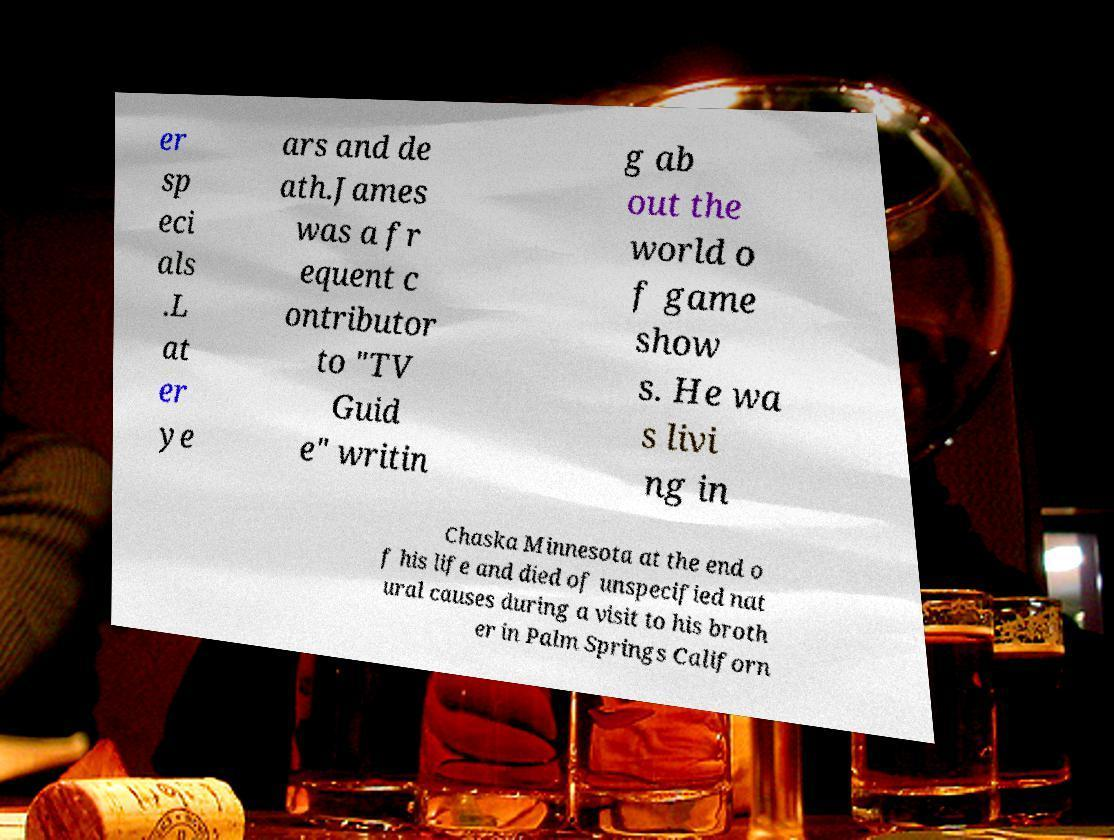There's text embedded in this image that I need extracted. Can you transcribe it verbatim? er sp eci als .L at er ye ars and de ath.James was a fr equent c ontributor to "TV Guid e" writin g ab out the world o f game show s. He wa s livi ng in Chaska Minnesota at the end o f his life and died of unspecified nat ural causes during a visit to his broth er in Palm Springs Californ 